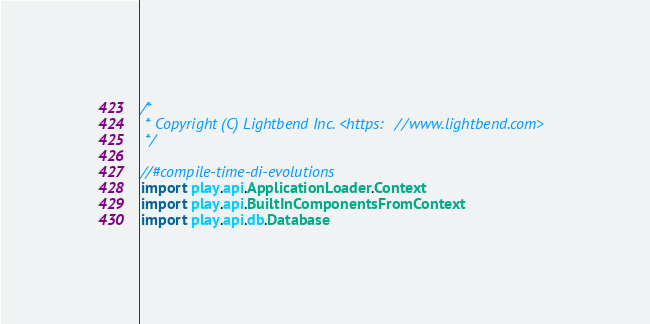<code> <loc_0><loc_0><loc_500><loc_500><_Scala_>/*
 * Copyright (C) Lightbend Inc. <https://www.lightbend.com>
 */

//#compile-time-di-evolutions
import play.api.ApplicationLoader.Context
import play.api.BuiltInComponentsFromContext
import play.api.db.Database</code> 